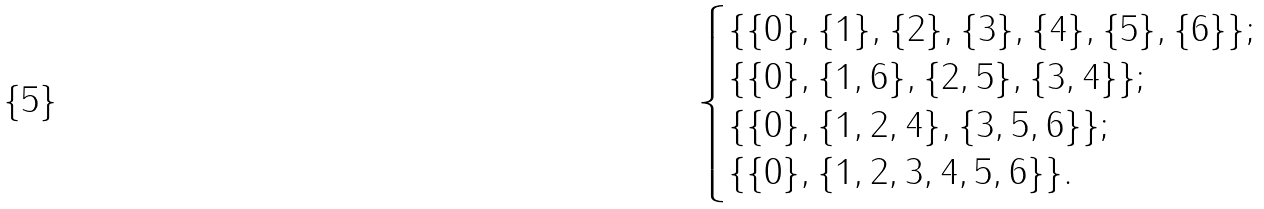Convert formula to latex. <formula><loc_0><loc_0><loc_500><loc_500>\begin{cases} \{ \{ 0 \} , \{ 1 \} , \{ 2 \} , \{ 3 \} , \{ 4 \} , \{ 5 \} , \{ 6 \} \} ; \\ \{ \{ 0 \} , \{ 1 , 6 \} , \{ 2 , 5 \} , \{ 3 , 4 \} \} ; \\ \{ \{ 0 \} , \{ 1 , 2 , 4 \} , \{ 3 , 5 , 6 \} \} ; \\ \{ \{ 0 \} , \{ 1 , 2 , 3 , 4 , 5 , 6 \} \} . \end{cases}</formula> 